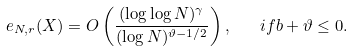<formula> <loc_0><loc_0><loc_500><loc_500>e _ { N , r } ( X ) = O \left ( \frac { ( \log \log N ) ^ { \gamma } } { ( \log N ) ^ { \vartheta - 1 / 2 } } \right ) , \quad i f b + \vartheta \leq 0 .</formula> 